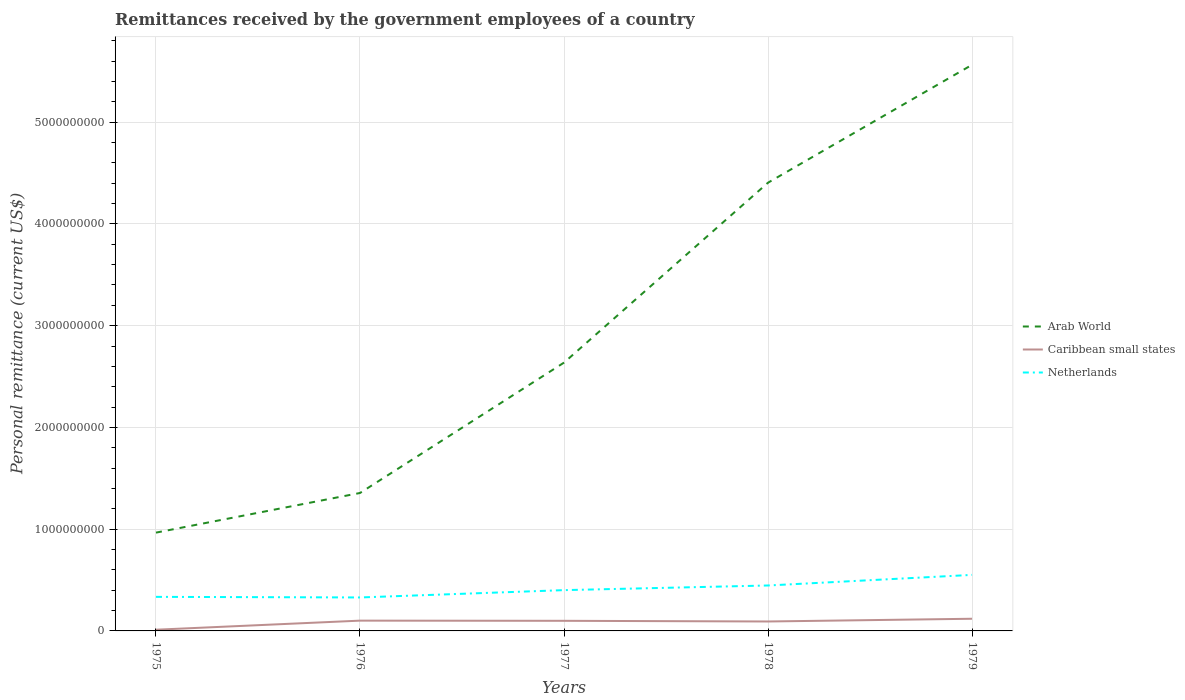How many different coloured lines are there?
Your answer should be compact. 3. Is the number of lines equal to the number of legend labels?
Provide a short and direct response. Yes. Across all years, what is the maximum remittances received by the government employees in Caribbean small states?
Offer a terse response. 1.18e+07. In which year was the remittances received by the government employees in Arab World maximum?
Your answer should be very brief. 1975. What is the total remittances received by the government employees in Arab World in the graph?
Offer a very short reply. -4.21e+09. What is the difference between the highest and the second highest remittances received by the government employees in Arab World?
Your answer should be compact. 4.60e+09. What is the difference between the highest and the lowest remittances received by the government employees in Netherlands?
Ensure brevity in your answer.  2. Is the remittances received by the government employees in Caribbean small states strictly greater than the remittances received by the government employees in Netherlands over the years?
Your answer should be very brief. Yes. How many years are there in the graph?
Keep it short and to the point. 5. Are the values on the major ticks of Y-axis written in scientific E-notation?
Your answer should be compact. No. Does the graph contain any zero values?
Keep it short and to the point. No. Does the graph contain grids?
Your answer should be very brief. Yes. What is the title of the graph?
Keep it short and to the point. Remittances received by the government employees of a country. What is the label or title of the Y-axis?
Provide a succinct answer. Personal remittance (current US$). What is the Personal remittance (current US$) in Arab World in 1975?
Your answer should be compact. 9.66e+08. What is the Personal remittance (current US$) of Caribbean small states in 1975?
Offer a terse response. 1.18e+07. What is the Personal remittance (current US$) in Netherlands in 1975?
Offer a very short reply. 3.35e+08. What is the Personal remittance (current US$) in Arab World in 1976?
Your answer should be very brief. 1.36e+09. What is the Personal remittance (current US$) of Caribbean small states in 1976?
Offer a terse response. 1.01e+08. What is the Personal remittance (current US$) in Netherlands in 1976?
Ensure brevity in your answer.  3.29e+08. What is the Personal remittance (current US$) in Arab World in 1977?
Your response must be concise. 2.64e+09. What is the Personal remittance (current US$) of Caribbean small states in 1977?
Ensure brevity in your answer.  9.94e+07. What is the Personal remittance (current US$) of Netherlands in 1977?
Give a very brief answer. 4.01e+08. What is the Personal remittance (current US$) in Arab World in 1978?
Offer a terse response. 4.41e+09. What is the Personal remittance (current US$) in Caribbean small states in 1978?
Ensure brevity in your answer.  9.27e+07. What is the Personal remittance (current US$) of Netherlands in 1978?
Provide a succinct answer. 4.47e+08. What is the Personal remittance (current US$) in Arab World in 1979?
Offer a terse response. 5.56e+09. What is the Personal remittance (current US$) of Caribbean small states in 1979?
Your answer should be compact. 1.20e+08. What is the Personal remittance (current US$) of Netherlands in 1979?
Your response must be concise. 5.51e+08. Across all years, what is the maximum Personal remittance (current US$) in Arab World?
Offer a terse response. 5.56e+09. Across all years, what is the maximum Personal remittance (current US$) in Caribbean small states?
Your answer should be very brief. 1.20e+08. Across all years, what is the maximum Personal remittance (current US$) in Netherlands?
Give a very brief answer. 5.51e+08. Across all years, what is the minimum Personal remittance (current US$) in Arab World?
Keep it short and to the point. 9.66e+08. Across all years, what is the minimum Personal remittance (current US$) of Caribbean small states?
Your answer should be very brief. 1.18e+07. Across all years, what is the minimum Personal remittance (current US$) of Netherlands?
Keep it short and to the point. 3.29e+08. What is the total Personal remittance (current US$) of Arab World in the graph?
Your response must be concise. 1.49e+1. What is the total Personal remittance (current US$) of Caribbean small states in the graph?
Your response must be concise. 4.25e+08. What is the total Personal remittance (current US$) in Netherlands in the graph?
Your response must be concise. 2.06e+09. What is the difference between the Personal remittance (current US$) of Arab World in 1975 and that in 1976?
Provide a short and direct response. -3.90e+08. What is the difference between the Personal remittance (current US$) in Caribbean small states in 1975 and that in 1976?
Your response must be concise. -8.93e+07. What is the difference between the Personal remittance (current US$) in Netherlands in 1975 and that in 1976?
Keep it short and to the point. 5.89e+06. What is the difference between the Personal remittance (current US$) of Arab World in 1975 and that in 1977?
Give a very brief answer. -1.67e+09. What is the difference between the Personal remittance (current US$) in Caribbean small states in 1975 and that in 1977?
Your response must be concise. -8.76e+07. What is the difference between the Personal remittance (current US$) in Netherlands in 1975 and that in 1977?
Ensure brevity in your answer.  -6.62e+07. What is the difference between the Personal remittance (current US$) of Arab World in 1975 and that in 1978?
Offer a very short reply. -3.44e+09. What is the difference between the Personal remittance (current US$) in Caribbean small states in 1975 and that in 1978?
Keep it short and to the point. -8.09e+07. What is the difference between the Personal remittance (current US$) of Netherlands in 1975 and that in 1978?
Ensure brevity in your answer.  -1.12e+08. What is the difference between the Personal remittance (current US$) in Arab World in 1975 and that in 1979?
Ensure brevity in your answer.  -4.60e+09. What is the difference between the Personal remittance (current US$) in Caribbean small states in 1975 and that in 1979?
Ensure brevity in your answer.  -1.08e+08. What is the difference between the Personal remittance (current US$) in Netherlands in 1975 and that in 1979?
Your answer should be compact. -2.16e+08. What is the difference between the Personal remittance (current US$) in Arab World in 1976 and that in 1977?
Make the answer very short. -1.28e+09. What is the difference between the Personal remittance (current US$) in Caribbean small states in 1976 and that in 1977?
Ensure brevity in your answer.  1.68e+06. What is the difference between the Personal remittance (current US$) in Netherlands in 1976 and that in 1977?
Make the answer very short. -7.21e+07. What is the difference between the Personal remittance (current US$) of Arab World in 1976 and that in 1978?
Offer a very short reply. -3.05e+09. What is the difference between the Personal remittance (current US$) of Caribbean small states in 1976 and that in 1978?
Provide a short and direct response. 8.38e+06. What is the difference between the Personal remittance (current US$) of Netherlands in 1976 and that in 1978?
Give a very brief answer. -1.18e+08. What is the difference between the Personal remittance (current US$) of Arab World in 1976 and that in 1979?
Give a very brief answer. -4.21e+09. What is the difference between the Personal remittance (current US$) in Caribbean small states in 1976 and that in 1979?
Keep it short and to the point. -1.85e+07. What is the difference between the Personal remittance (current US$) in Netherlands in 1976 and that in 1979?
Give a very brief answer. -2.22e+08. What is the difference between the Personal remittance (current US$) of Arab World in 1977 and that in 1978?
Give a very brief answer. -1.77e+09. What is the difference between the Personal remittance (current US$) in Caribbean small states in 1977 and that in 1978?
Make the answer very short. 6.70e+06. What is the difference between the Personal remittance (current US$) in Netherlands in 1977 and that in 1978?
Provide a short and direct response. -4.56e+07. What is the difference between the Personal remittance (current US$) of Arab World in 1977 and that in 1979?
Offer a terse response. -2.93e+09. What is the difference between the Personal remittance (current US$) of Caribbean small states in 1977 and that in 1979?
Provide a short and direct response. -2.02e+07. What is the difference between the Personal remittance (current US$) in Netherlands in 1977 and that in 1979?
Ensure brevity in your answer.  -1.50e+08. What is the difference between the Personal remittance (current US$) in Arab World in 1978 and that in 1979?
Your answer should be compact. -1.16e+09. What is the difference between the Personal remittance (current US$) in Caribbean small states in 1978 and that in 1979?
Your response must be concise. -2.69e+07. What is the difference between the Personal remittance (current US$) of Netherlands in 1978 and that in 1979?
Keep it short and to the point. -1.04e+08. What is the difference between the Personal remittance (current US$) of Arab World in 1975 and the Personal remittance (current US$) of Caribbean small states in 1976?
Give a very brief answer. 8.65e+08. What is the difference between the Personal remittance (current US$) in Arab World in 1975 and the Personal remittance (current US$) in Netherlands in 1976?
Provide a succinct answer. 6.37e+08. What is the difference between the Personal remittance (current US$) in Caribbean small states in 1975 and the Personal remittance (current US$) in Netherlands in 1976?
Provide a succinct answer. -3.17e+08. What is the difference between the Personal remittance (current US$) of Arab World in 1975 and the Personal remittance (current US$) of Caribbean small states in 1977?
Make the answer very short. 8.67e+08. What is the difference between the Personal remittance (current US$) of Arab World in 1975 and the Personal remittance (current US$) of Netherlands in 1977?
Offer a terse response. 5.65e+08. What is the difference between the Personal remittance (current US$) of Caribbean small states in 1975 and the Personal remittance (current US$) of Netherlands in 1977?
Make the answer very short. -3.89e+08. What is the difference between the Personal remittance (current US$) in Arab World in 1975 and the Personal remittance (current US$) in Caribbean small states in 1978?
Your answer should be very brief. 8.73e+08. What is the difference between the Personal remittance (current US$) of Arab World in 1975 and the Personal remittance (current US$) of Netherlands in 1978?
Provide a short and direct response. 5.20e+08. What is the difference between the Personal remittance (current US$) of Caribbean small states in 1975 and the Personal remittance (current US$) of Netherlands in 1978?
Ensure brevity in your answer.  -4.35e+08. What is the difference between the Personal remittance (current US$) in Arab World in 1975 and the Personal remittance (current US$) in Caribbean small states in 1979?
Keep it short and to the point. 8.47e+08. What is the difference between the Personal remittance (current US$) in Arab World in 1975 and the Personal remittance (current US$) in Netherlands in 1979?
Offer a terse response. 4.15e+08. What is the difference between the Personal remittance (current US$) of Caribbean small states in 1975 and the Personal remittance (current US$) of Netherlands in 1979?
Keep it short and to the point. -5.39e+08. What is the difference between the Personal remittance (current US$) of Arab World in 1976 and the Personal remittance (current US$) of Caribbean small states in 1977?
Give a very brief answer. 1.26e+09. What is the difference between the Personal remittance (current US$) of Arab World in 1976 and the Personal remittance (current US$) of Netherlands in 1977?
Provide a succinct answer. 9.55e+08. What is the difference between the Personal remittance (current US$) of Caribbean small states in 1976 and the Personal remittance (current US$) of Netherlands in 1977?
Ensure brevity in your answer.  -3.00e+08. What is the difference between the Personal remittance (current US$) in Arab World in 1976 and the Personal remittance (current US$) in Caribbean small states in 1978?
Provide a short and direct response. 1.26e+09. What is the difference between the Personal remittance (current US$) of Arab World in 1976 and the Personal remittance (current US$) of Netherlands in 1978?
Your answer should be very brief. 9.09e+08. What is the difference between the Personal remittance (current US$) in Caribbean small states in 1976 and the Personal remittance (current US$) in Netherlands in 1978?
Provide a succinct answer. -3.45e+08. What is the difference between the Personal remittance (current US$) in Arab World in 1976 and the Personal remittance (current US$) in Caribbean small states in 1979?
Keep it short and to the point. 1.24e+09. What is the difference between the Personal remittance (current US$) of Arab World in 1976 and the Personal remittance (current US$) of Netherlands in 1979?
Offer a terse response. 8.05e+08. What is the difference between the Personal remittance (current US$) in Caribbean small states in 1976 and the Personal remittance (current US$) in Netherlands in 1979?
Make the answer very short. -4.50e+08. What is the difference between the Personal remittance (current US$) of Arab World in 1977 and the Personal remittance (current US$) of Caribbean small states in 1978?
Provide a succinct answer. 2.54e+09. What is the difference between the Personal remittance (current US$) in Arab World in 1977 and the Personal remittance (current US$) in Netherlands in 1978?
Give a very brief answer. 2.19e+09. What is the difference between the Personal remittance (current US$) in Caribbean small states in 1977 and the Personal remittance (current US$) in Netherlands in 1978?
Make the answer very short. -3.47e+08. What is the difference between the Personal remittance (current US$) of Arab World in 1977 and the Personal remittance (current US$) of Caribbean small states in 1979?
Keep it short and to the point. 2.52e+09. What is the difference between the Personal remittance (current US$) of Arab World in 1977 and the Personal remittance (current US$) of Netherlands in 1979?
Your response must be concise. 2.09e+09. What is the difference between the Personal remittance (current US$) of Caribbean small states in 1977 and the Personal remittance (current US$) of Netherlands in 1979?
Provide a short and direct response. -4.51e+08. What is the difference between the Personal remittance (current US$) of Arab World in 1978 and the Personal remittance (current US$) of Caribbean small states in 1979?
Your answer should be compact. 4.29e+09. What is the difference between the Personal remittance (current US$) of Arab World in 1978 and the Personal remittance (current US$) of Netherlands in 1979?
Your answer should be compact. 3.85e+09. What is the difference between the Personal remittance (current US$) in Caribbean small states in 1978 and the Personal remittance (current US$) in Netherlands in 1979?
Keep it short and to the point. -4.58e+08. What is the average Personal remittance (current US$) in Arab World per year?
Keep it short and to the point. 2.99e+09. What is the average Personal remittance (current US$) of Caribbean small states per year?
Offer a terse response. 8.49e+07. What is the average Personal remittance (current US$) in Netherlands per year?
Make the answer very short. 4.12e+08. In the year 1975, what is the difference between the Personal remittance (current US$) of Arab World and Personal remittance (current US$) of Caribbean small states?
Your response must be concise. 9.54e+08. In the year 1975, what is the difference between the Personal remittance (current US$) in Arab World and Personal remittance (current US$) in Netherlands?
Your answer should be very brief. 6.31e+08. In the year 1975, what is the difference between the Personal remittance (current US$) of Caribbean small states and Personal remittance (current US$) of Netherlands?
Offer a very short reply. -3.23e+08. In the year 1976, what is the difference between the Personal remittance (current US$) in Arab World and Personal remittance (current US$) in Caribbean small states?
Make the answer very short. 1.25e+09. In the year 1976, what is the difference between the Personal remittance (current US$) of Arab World and Personal remittance (current US$) of Netherlands?
Provide a succinct answer. 1.03e+09. In the year 1976, what is the difference between the Personal remittance (current US$) in Caribbean small states and Personal remittance (current US$) in Netherlands?
Give a very brief answer. -2.28e+08. In the year 1977, what is the difference between the Personal remittance (current US$) in Arab World and Personal remittance (current US$) in Caribbean small states?
Offer a terse response. 2.54e+09. In the year 1977, what is the difference between the Personal remittance (current US$) of Arab World and Personal remittance (current US$) of Netherlands?
Ensure brevity in your answer.  2.24e+09. In the year 1977, what is the difference between the Personal remittance (current US$) in Caribbean small states and Personal remittance (current US$) in Netherlands?
Offer a very short reply. -3.02e+08. In the year 1978, what is the difference between the Personal remittance (current US$) in Arab World and Personal remittance (current US$) in Caribbean small states?
Keep it short and to the point. 4.31e+09. In the year 1978, what is the difference between the Personal remittance (current US$) in Arab World and Personal remittance (current US$) in Netherlands?
Ensure brevity in your answer.  3.96e+09. In the year 1978, what is the difference between the Personal remittance (current US$) of Caribbean small states and Personal remittance (current US$) of Netherlands?
Make the answer very short. -3.54e+08. In the year 1979, what is the difference between the Personal remittance (current US$) of Arab World and Personal remittance (current US$) of Caribbean small states?
Keep it short and to the point. 5.44e+09. In the year 1979, what is the difference between the Personal remittance (current US$) of Arab World and Personal remittance (current US$) of Netherlands?
Offer a very short reply. 5.01e+09. In the year 1979, what is the difference between the Personal remittance (current US$) in Caribbean small states and Personal remittance (current US$) in Netherlands?
Give a very brief answer. -4.31e+08. What is the ratio of the Personal remittance (current US$) in Arab World in 1975 to that in 1976?
Provide a short and direct response. 0.71. What is the ratio of the Personal remittance (current US$) in Caribbean small states in 1975 to that in 1976?
Offer a very short reply. 0.12. What is the ratio of the Personal remittance (current US$) of Netherlands in 1975 to that in 1976?
Offer a very short reply. 1.02. What is the ratio of the Personal remittance (current US$) of Arab World in 1975 to that in 1977?
Make the answer very short. 0.37. What is the ratio of the Personal remittance (current US$) of Caribbean small states in 1975 to that in 1977?
Keep it short and to the point. 0.12. What is the ratio of the Personal remittance (current US$) in Netherlands in 1975 to that in 1977?
Your response must be concise. 0.83. What is the ratio of the Personal remittance (current US$) of Arab World in 1975 to that in 1978?
Your response must be concise. 0.22. What is the ratio of the Personal remittance (current US$) of Caribbean small states in 1975 to that in 1978?
Your answer should be very brief. 0.13. What is the ratio of the Personal remittance (current US$) of Netherlands in 1975 to that in 1978?
Offer a very short reply. 0.75. What is the ratio of the Personal remittance (current US$) in Arab World in 1975 to that in 1979?
Ensure brevity in your answer.  0.17. What is the ratio of the Personal remittance (current US$) in Caribbean small states in 1975 to that in 1979?
Provide a succinct answer. 0.1. What is the ratio of the Personal remittance (current US$) in Netherlands in 1975 to that in 1979?
Your answer should be very brief. 0.61. What is the ratio of the Personal remittance (current US$) in Arab World in 1976 to that in 1977?
Offer a terse response. 0.51. What is the ratio of the Personal remittance (current US$) in Caribbean small states in 1976 to that in 1977?
Offer a very short reply. 1.02. What is the ratio of the Personal remittance (current US$) in Netherlands in 1976 to that in 1977?
Provide a succinct answer. 0.82. What is the ratio of the Personal remittance (current US$) in Arab World in 1976 to that in 1978?
Provide a short and direct response. 0.31. What is the ratio of the Personal remittance (current US$) in Caribbean small states in 1976 to that in 1978?
Offer a terse response. 1.09. What is the ratio of the Personal remittance (current US$) in Netherlands in 1976 to that in 1978?
Provide a short and direct response. 0.74. What is the ratio of the Personal remittance (current US$) in Arab World in 1976 to that in 1979?
Offer a very short reply. 0.24. What is the ratio of the Personal remittance (current US$) of Caribbean small states in 1976 to that in 1979?
Give a very brief answer. 0.85. What is the ratio of the Personal remittance (current US$) in Netherlands in 1976 to that in 1979?
Provide a short and direct response. 0.6. What is the ratio of the Personal remittance (current US$) in Arab World in 1977 to that in 1978?
Provide a succinct answer. 0.6. What is the ratio of the Personal remittance (current US$) in Caribbean small states in 1977 to that in 1978?
Give a very brief answer. 1.07. What is the ratio of the Personal remittance (current US$) in Netherlands in 1977 to that in 1978?
Offer a very short reply. 0.9. What is the ratio of the Personal remittance (current US$) in Arab World in 1977 to that in 1979?
Your response must be concise. 0.47. What is the ratio of the Personal remittance (current US$) in Caribbean small states in 1977 to that in 1979?
Your response must be concise. 0.83. What is the ratio of the Personal remittance (current US$) of Netherlands in 1977 to that in 1979?
Give a very brief answer. 0.73. What is the ratio of the Personal remittance (current US$) of Arab World in 1978 to that in 1979?
Give a very brief answer. 0.79. What is the ratio of the Personal remittance (current US$) of Caribbean small states in 1978 to that in 1979?
Offer a very short reply. 0.78. What is the ratio of the Personal remittance (current US$) in Netherlands in 1978 to that in 1979?
Your response must be concise. 0.81. What is the difference between the highest and the second highest Personal remittance (current US$) in Arab World?
Make the answer very short. 1.16e+09. What is the difference between the highest and the second highest Personal remittance (current US$) in Caribbean small states?
Keep it short and to the point. 1.85e+07. What is the difference between the highest and the second highest Personal remittance (current US$) in Netherlands?
Your answer should be very brief. 1.04e+08. What is the difference between the highest and the lowest Personal remittance (current US$) in Arab World?
Offer a terse response. 4.60e+09. What is the difference between the highest and the lowest Personal remittance (current US$) of Caribbean small states?
Your response must be concise. 1.08e+08. What is the difference between the highest and the lowest Personal remittance (current US$) in Netherlands?
Your answer should be compact. 2.22e+08. 